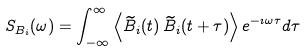Convert formula to latex. <formula><loc_0><loc_0><loc_500><loc_500>S _ { B _ { i } } ( \omega ) = \int _ { - \infty } ^ { \infty } \left \langle \widetilde { B } _ { i } ( t ) \, \widetilde { B } _ { i } ( t + \tau ) \right \rangle e ^ { - \imath \omega \tau } d \tau</formula> 